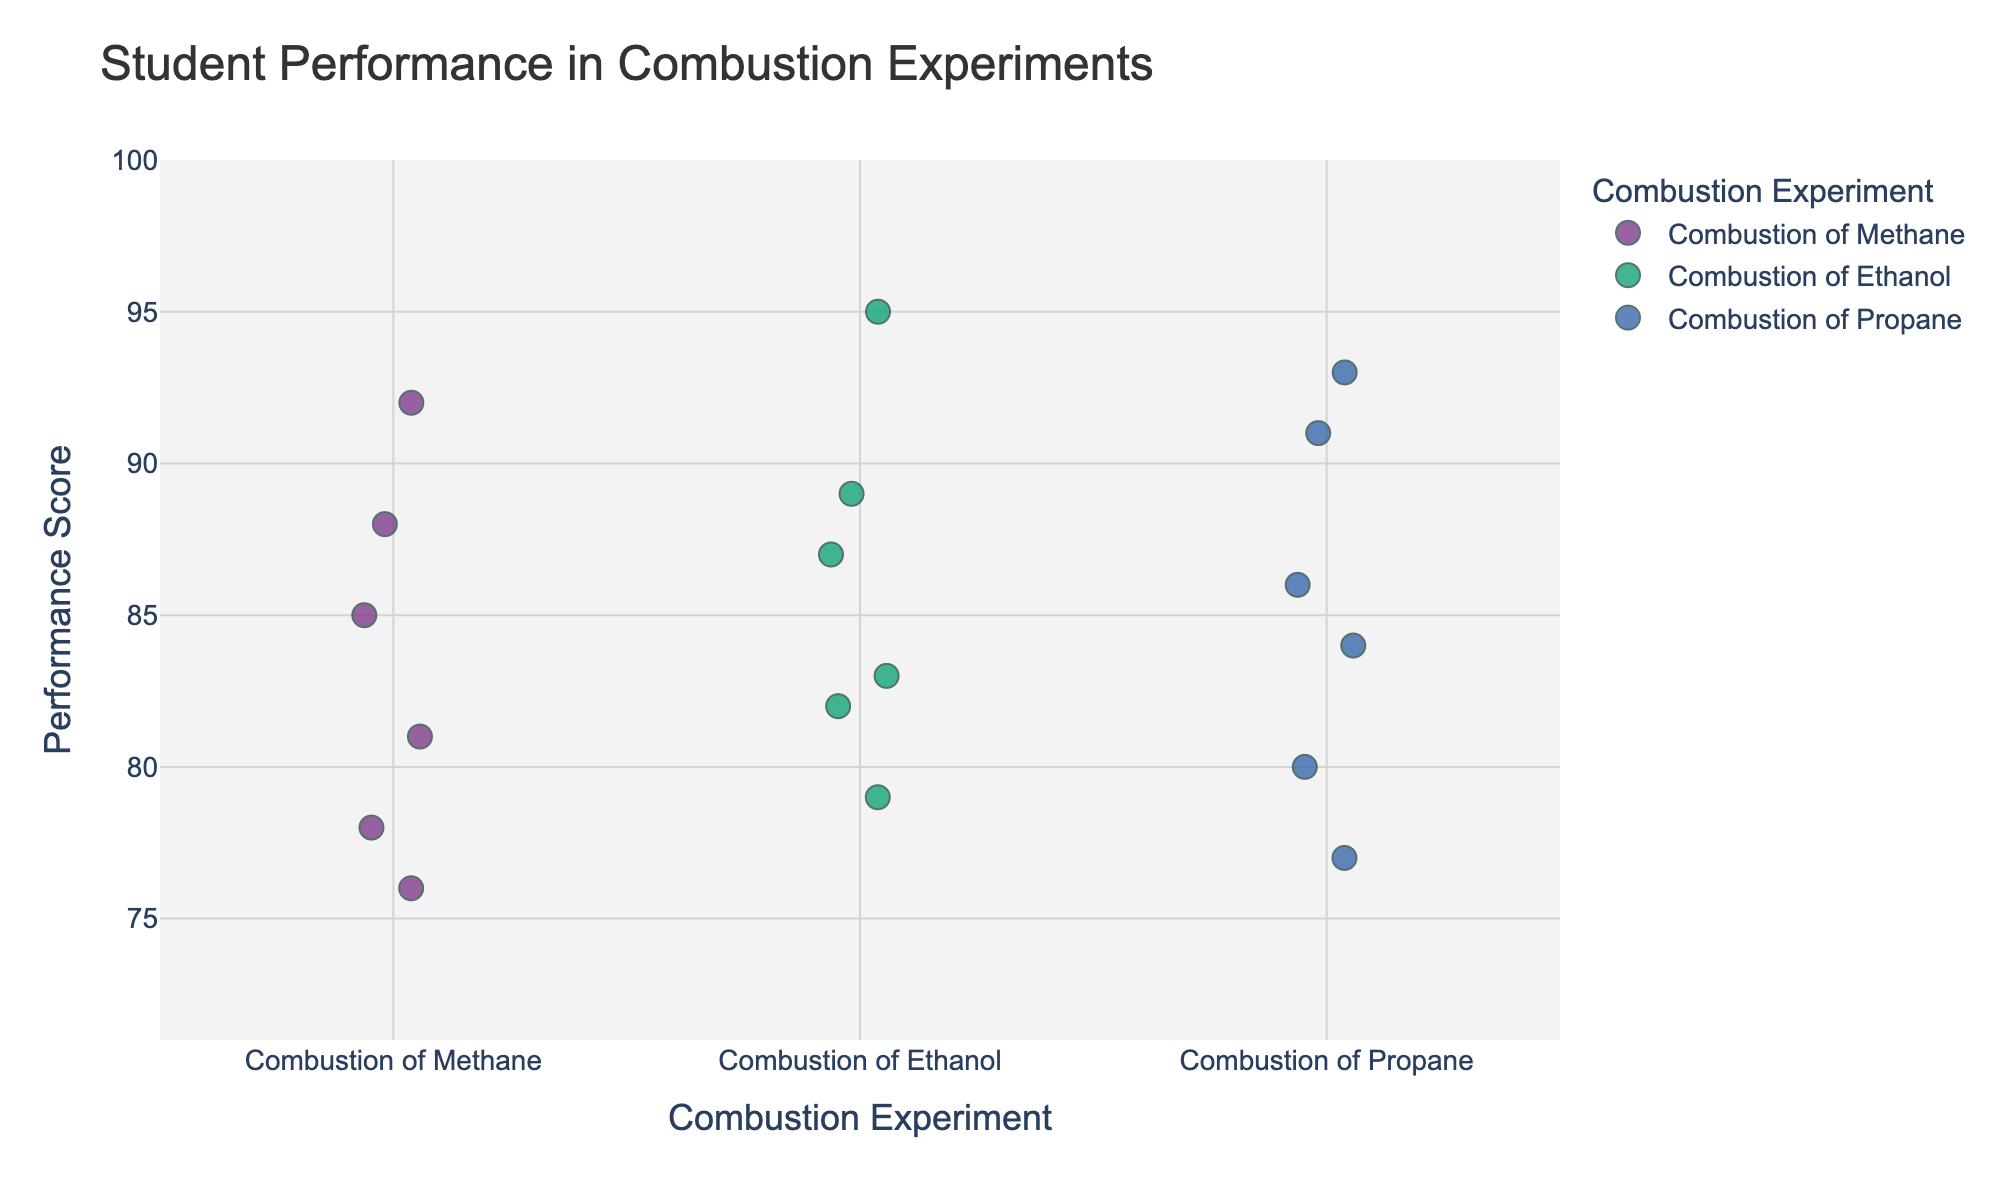Which combustion experiment had the highest performance score? By looking at the highest position on the y-axis for each "Experiment" category, we note that "Combustion of Propane" reaches the highest score of 93.
Answer: Combustion of Propane How many students participated in the Combustion of Methane experiment? Count the number of points corresponding to the "Combustion of Methane" category on the x-axis of the plot.
Answer: 6 What is the average score of students in the Combustion of Ethanol experiment? Add the scores for the Combustion of Ethanol group (89, 83, 95, 79, 87, 82) and divide by the number of students (6): (89 + 83 + 95 + 79 + 87 + 82) / 6 = 86.
Answer: 86 Which experiment has the lowest overall score observed, and what is that score? Identify the lowest point on the y-axis for each experiment category; "Combustion of Methane" has the lowest score at 76.
Answer: Combustion of Methane, 76 How does the median score for the Combustion of Propane compare to that of Combustion of Methane? First, find the median scores: for Combustion of Propane (77, 80, 84, 86, 91, 93), the median is (84+86)/2 = 85; for Combustion of Methane (76, 78, 81, 85, 88, 92), the median is (81+85)/2 = 83. So, the median score for Combustion of Propane is higher.
Answer: Higher What range of scores is observed in the Combustion of Ethanol experiment? Find the minimum and maximum scores for Combustion of Ethanol (79, 82, 83, 87, 89, 95) to get the range: 95 - 79 = 16.
Answer: 16 Is there any overlap in student scores between different combustion experiments? By examining the spread of points on the y-axis, we see that there is an overlap in score ranges where students from different combustion experiments can have similar scores.
Answer: Yes Which combustion experiment has the most varied student performance scores? By observing the spread of points along the y-axis, we note that Combustion of Ethanol has the widest range (95 - 79 = 16), indicating the most varied performance.
Answer: Combustion of Ethanol 